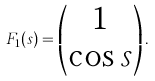<formula> <loc_0><loc_0><loc_500><loc_500>F _ { 1 } ( s ) = \left ( \begin{matrix} 1 \\ \cos s \end{matrix} \right ) .</formula> 